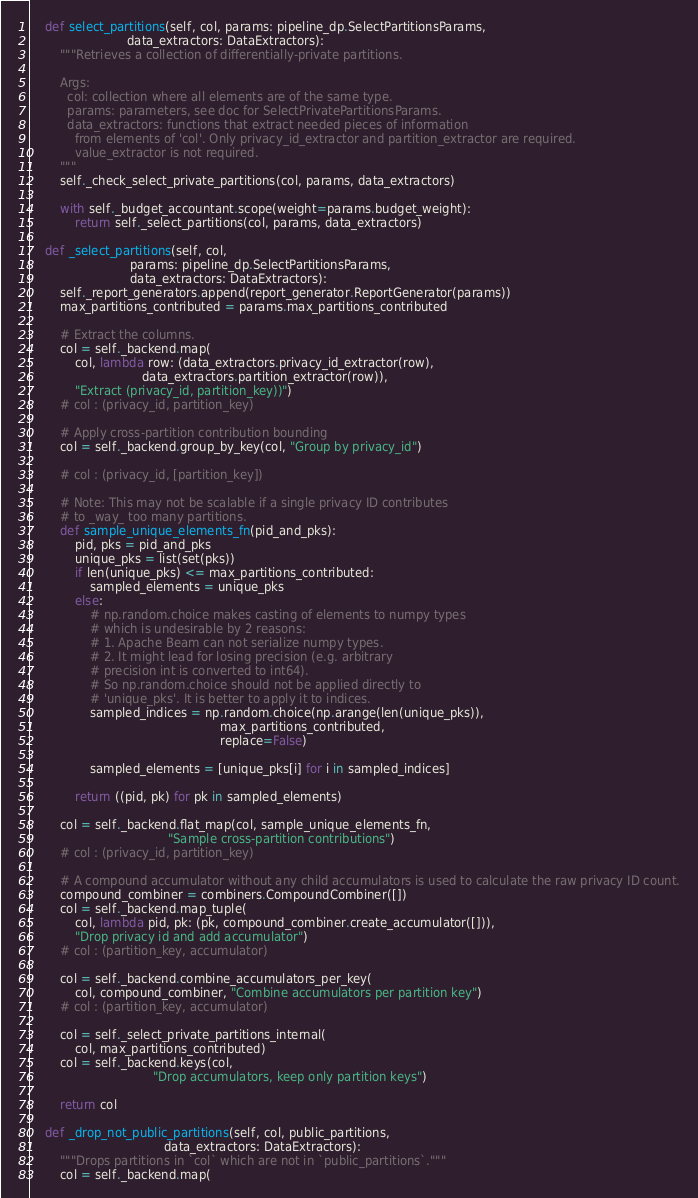<code> <loc_0><loc_0><loc_500><loc_500><_Python_>
    def select_partitions(self, col, params: pipeline_dp.SelectPartitionsParams,
                          data_extractors: DataExtractors):
        """Retrieves a collection of differentially-private partitions.

        Args:
          col: collection where all elements are of the same type.
          params: parameters, see doc for SelectPrivatePartitionsParams.
          data_extractors: functions that extract needed pieces of information
            from elements of 'col'. Only privacy_id_extractor and partition_extractor are required.
            value_extractor is not required.
        """
        self._check_select_private_partitions(col, params, data_extractors)

        with self._budget_accountant.scope(weight=params.budget_weight):
            return self._select_partitions(col, params, data_extractors)

    def _select_partitions(self, col,
                           params: pipeline_dp.SelectPartitionsParams,
                           data_extractors: DataExtractors):
        self._report_generators.append(report_generator.ReportGenerator(params))
        max_partitions_contributed = params.max_partitions_contributed

        # Extract the columns.
        col = self._backend.map(
            col, lambda row: (data_extractors.privacy_id_extractor(row),
                              data_extractors.partition_extractor(row)),
            "Extract (privacy_id, partition_key))")
        # col : (privacy_id, partition_key)

        # Apply cross-partition contribution bounding
        col = self._backend.group_by_key(col, "Group by privacy_id")

        # col : (privacy_id, [partition_key])

        # Note: This may not be scalable if a single privacy ID contributes
        # to _way_ too many partitions.
        def sample_unique_elements_fn(pid_and_pks):
            pid, pks = pid_and_pks
            unique_pks = list(set(pks))
            if len(unique_pks) <= max_partitions_contributed:
                sampled_elements = unique_pks
            else:
                # np.random.choice makes casting of elements to numpy types
                # which is undesirable by 2 reasons:
                # 1. Apache Beam can not serialize numpy types.
                # 2. It might lead for losing precision (e.g. arbitrary
                # precision int is converted to int64).
                # So np.random.choice should not be applied directly to
                # 'unique_pks'. It is better to apply it to indices.
                sampled_indices = np.random.choice(np.arange(len(unique_pks)),
                                                   max_partitions_contributed,
                                                   replace=False)

                sampled_elements = [unique_pks[i] for i in sampled_indices]

            return ((pid, pk) for pk in sampled_elements)

        col = self._backend.flat_map(col, sample_unique_elements_fn,
                                     "Sample cross-partition contributions")
        # col : (privacy_id, partition_key)

        # A compound accumulator without any child accumulators is used to calculate the raw privacy ID count.
        compound_combiner = combiners.CompoundCombiner([])
        col = self._backend.map_tuple(
            col, lambda pid, pk: (pk, compound_combiner.create_accumulator([])),
            "Drop privacy id and add accumulator")
        # col : (partition_key, accumulator)

        col = self._backend.combine_accumulators_per_key(
            col, compound_combiner, "Combine accumulators per partition key")
        # col : (partition_key, accumulator)

        col = self._select_private_partitions_internal(
            col, max_partitions_contributed)
        col = self._backend.keys(col,
                                 "Drop accumulators, keep only partition keys")

        return col

    def _drop_not_public_partitions(self, col, public_partitions,
                                    data_extractors: DataExtractors):
        """Drops partitions in `col` which are not in `public_partitions`."""
        col = self._backend.map(</code> 